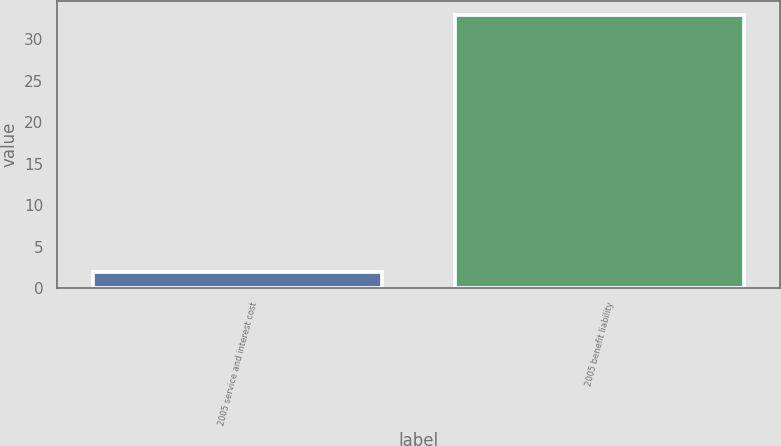Convert chart to OTSL. <chart><loc_0><loc_0><loc_500><loc_500><bar_chart><fcel>2005 service and interest cost<fcel>2005 benefit liability<nl><fcel>2<fcel>33<nl></chart> 